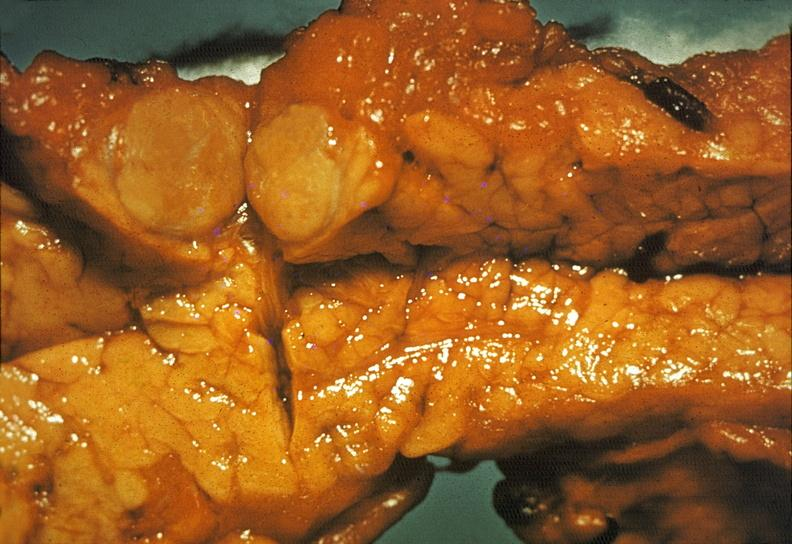what is present?
Answer the question using a single word or phrase. Pancreas 